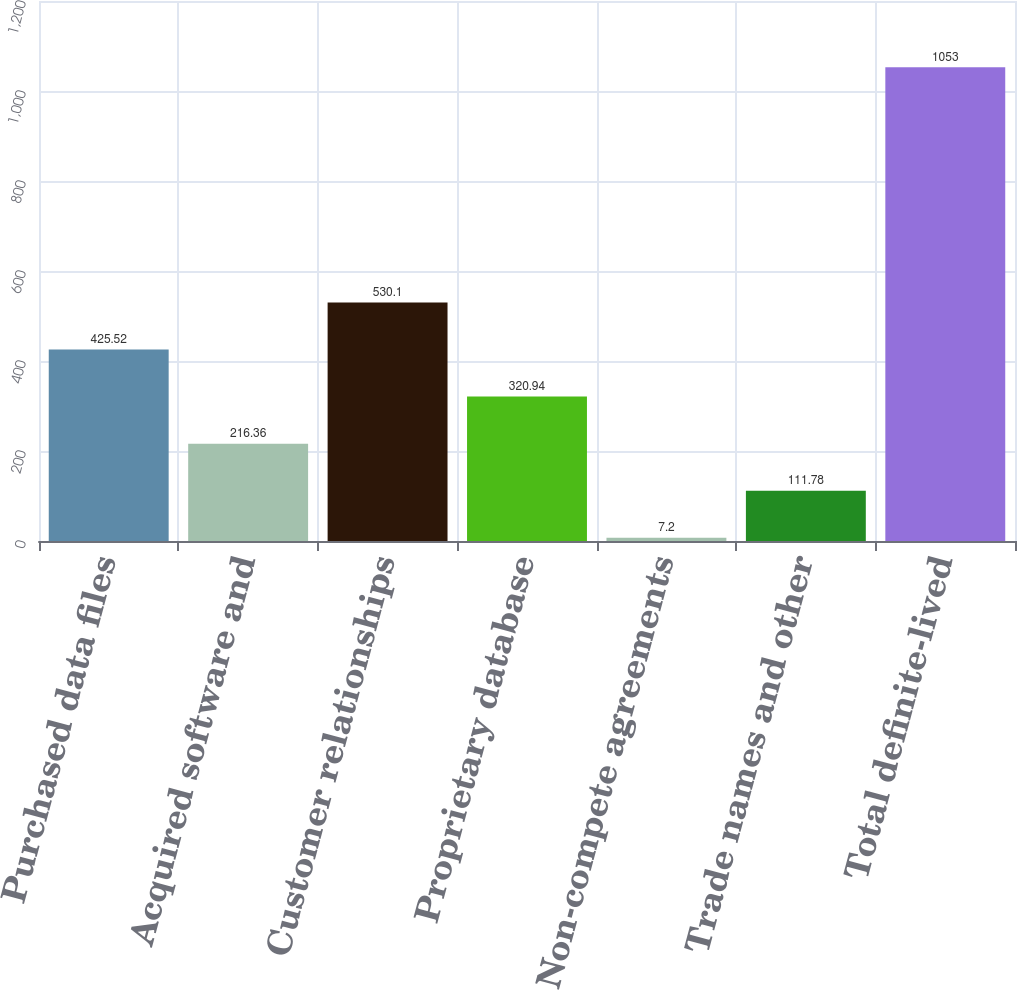Convert chart to OTSL. <chart><loc_0><loc_0><loc_500><loc_500><bar_chart><fcel>Purchased data files<fcel>Acquired software and<fcel>Customer relationships<fcel>Proprietary database<fcel>Non-compete agreements<fcel>Trade names and other<fcel>Total definite-lived<nl><fcel>425.52<fcel>216.36<fcel>530.1<fcel>320.94<fcel>7.2<fcel>111.78<fcel>1053<nl></chart> 